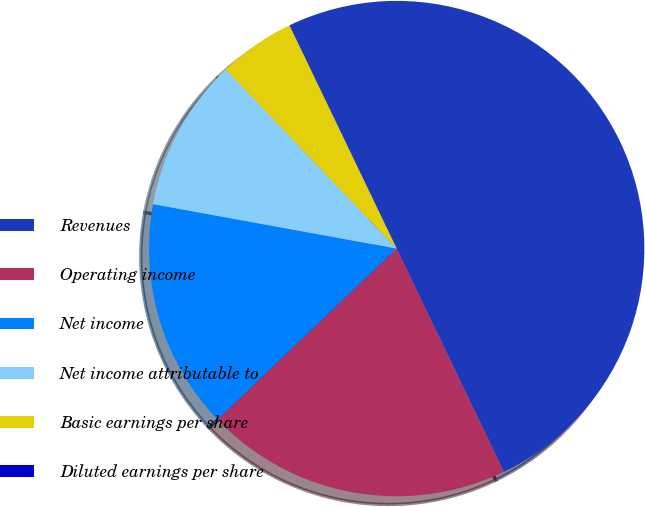<chart> <loc_0><loc_0><loc_500><loc_500><pie_chart><fcel>Revenues<fcel>Operating income<fcel>Net income<fcel>Net income attributable to<fcel>Basic earnings per share<fcel>Diluted earnings per share<nl><fcel>50.0%<fcel>20.0%<fcel>15.0%<fcel>10.0%<fcel>5.0%<fcel>0.0%<nl></chart> 